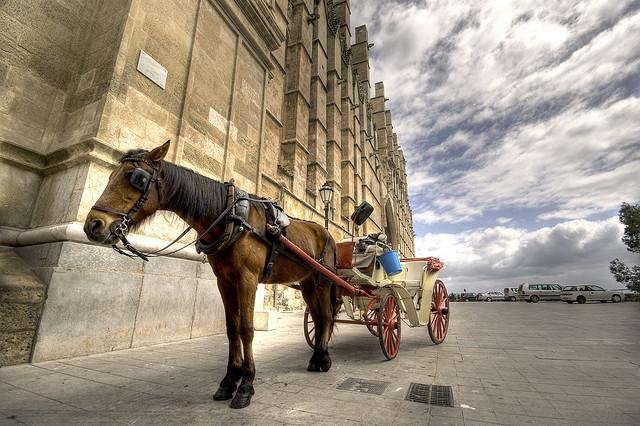This animal is most closely related to what other animal? donkey 